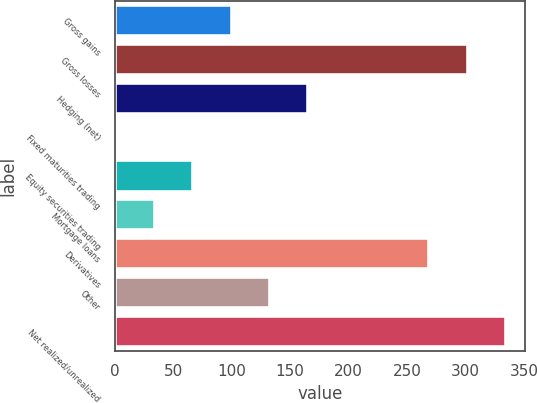Convert chart. <chart><loc_0><loc_0><loc_500><loc_500><bar_chart><fcel>Gross gains<fcel>Gross losses<fcel>Hedging (net)<fcel>Fixed maturities trading<fcel>Equity securities trading<fcel>Mortgage loans<fcel>Derivatives<fcel>Other<fcel>Net realized/unrealized<nl><fcel>99.83<fcel>301.91<fcel>165.25<fcel>1.7<fcel>67.12<fcel>34.41<fcel>269.2<fcel>132.54<fcel>334.62<nl></chart> 